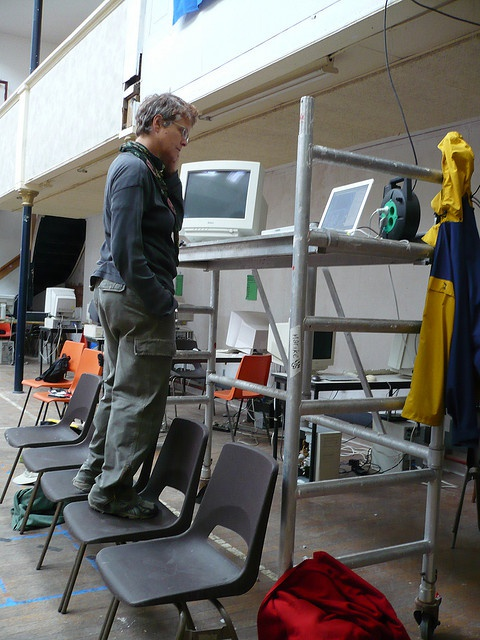Describe the objects in this image and their specific colors. I can see people in darkgray, black, and gray tones, chair in darkgray, gray, and black tones, backpack in darkgray, maroon, black, brown, and gray tones, chair in darkgray, black, and gray tones, and tv in darkgray, white, and gray tones in this image. 